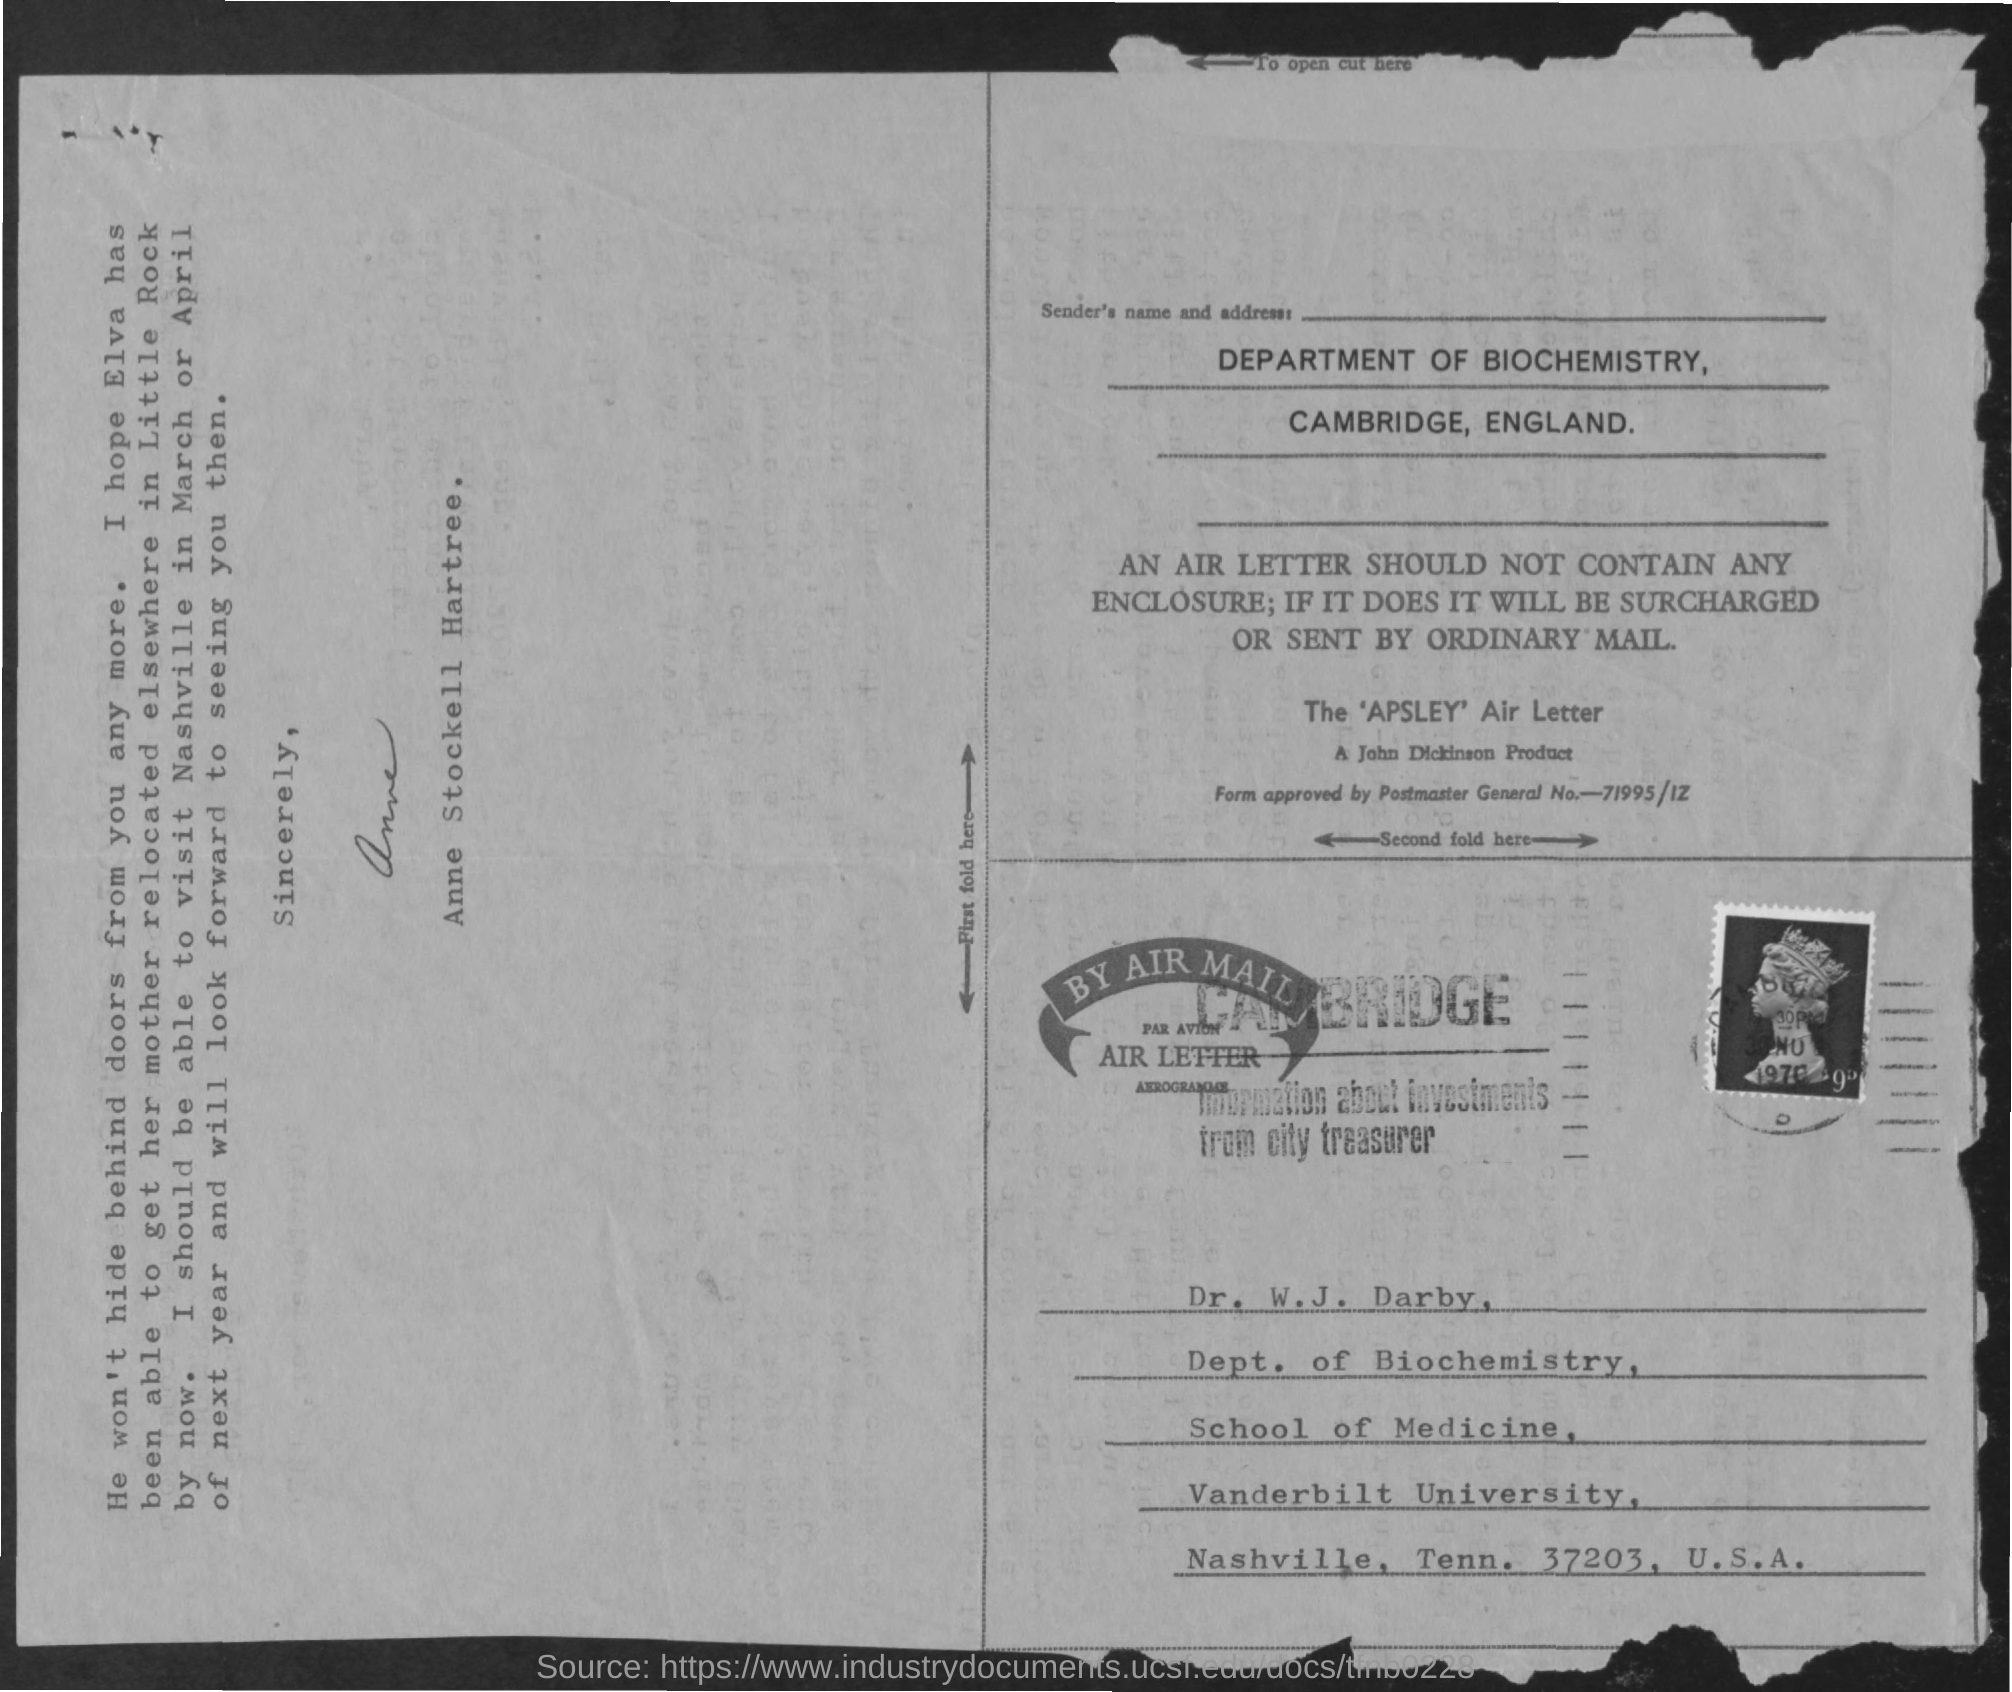Who has signed the letter?
Offer a terse response. Anne stockell hartree. 